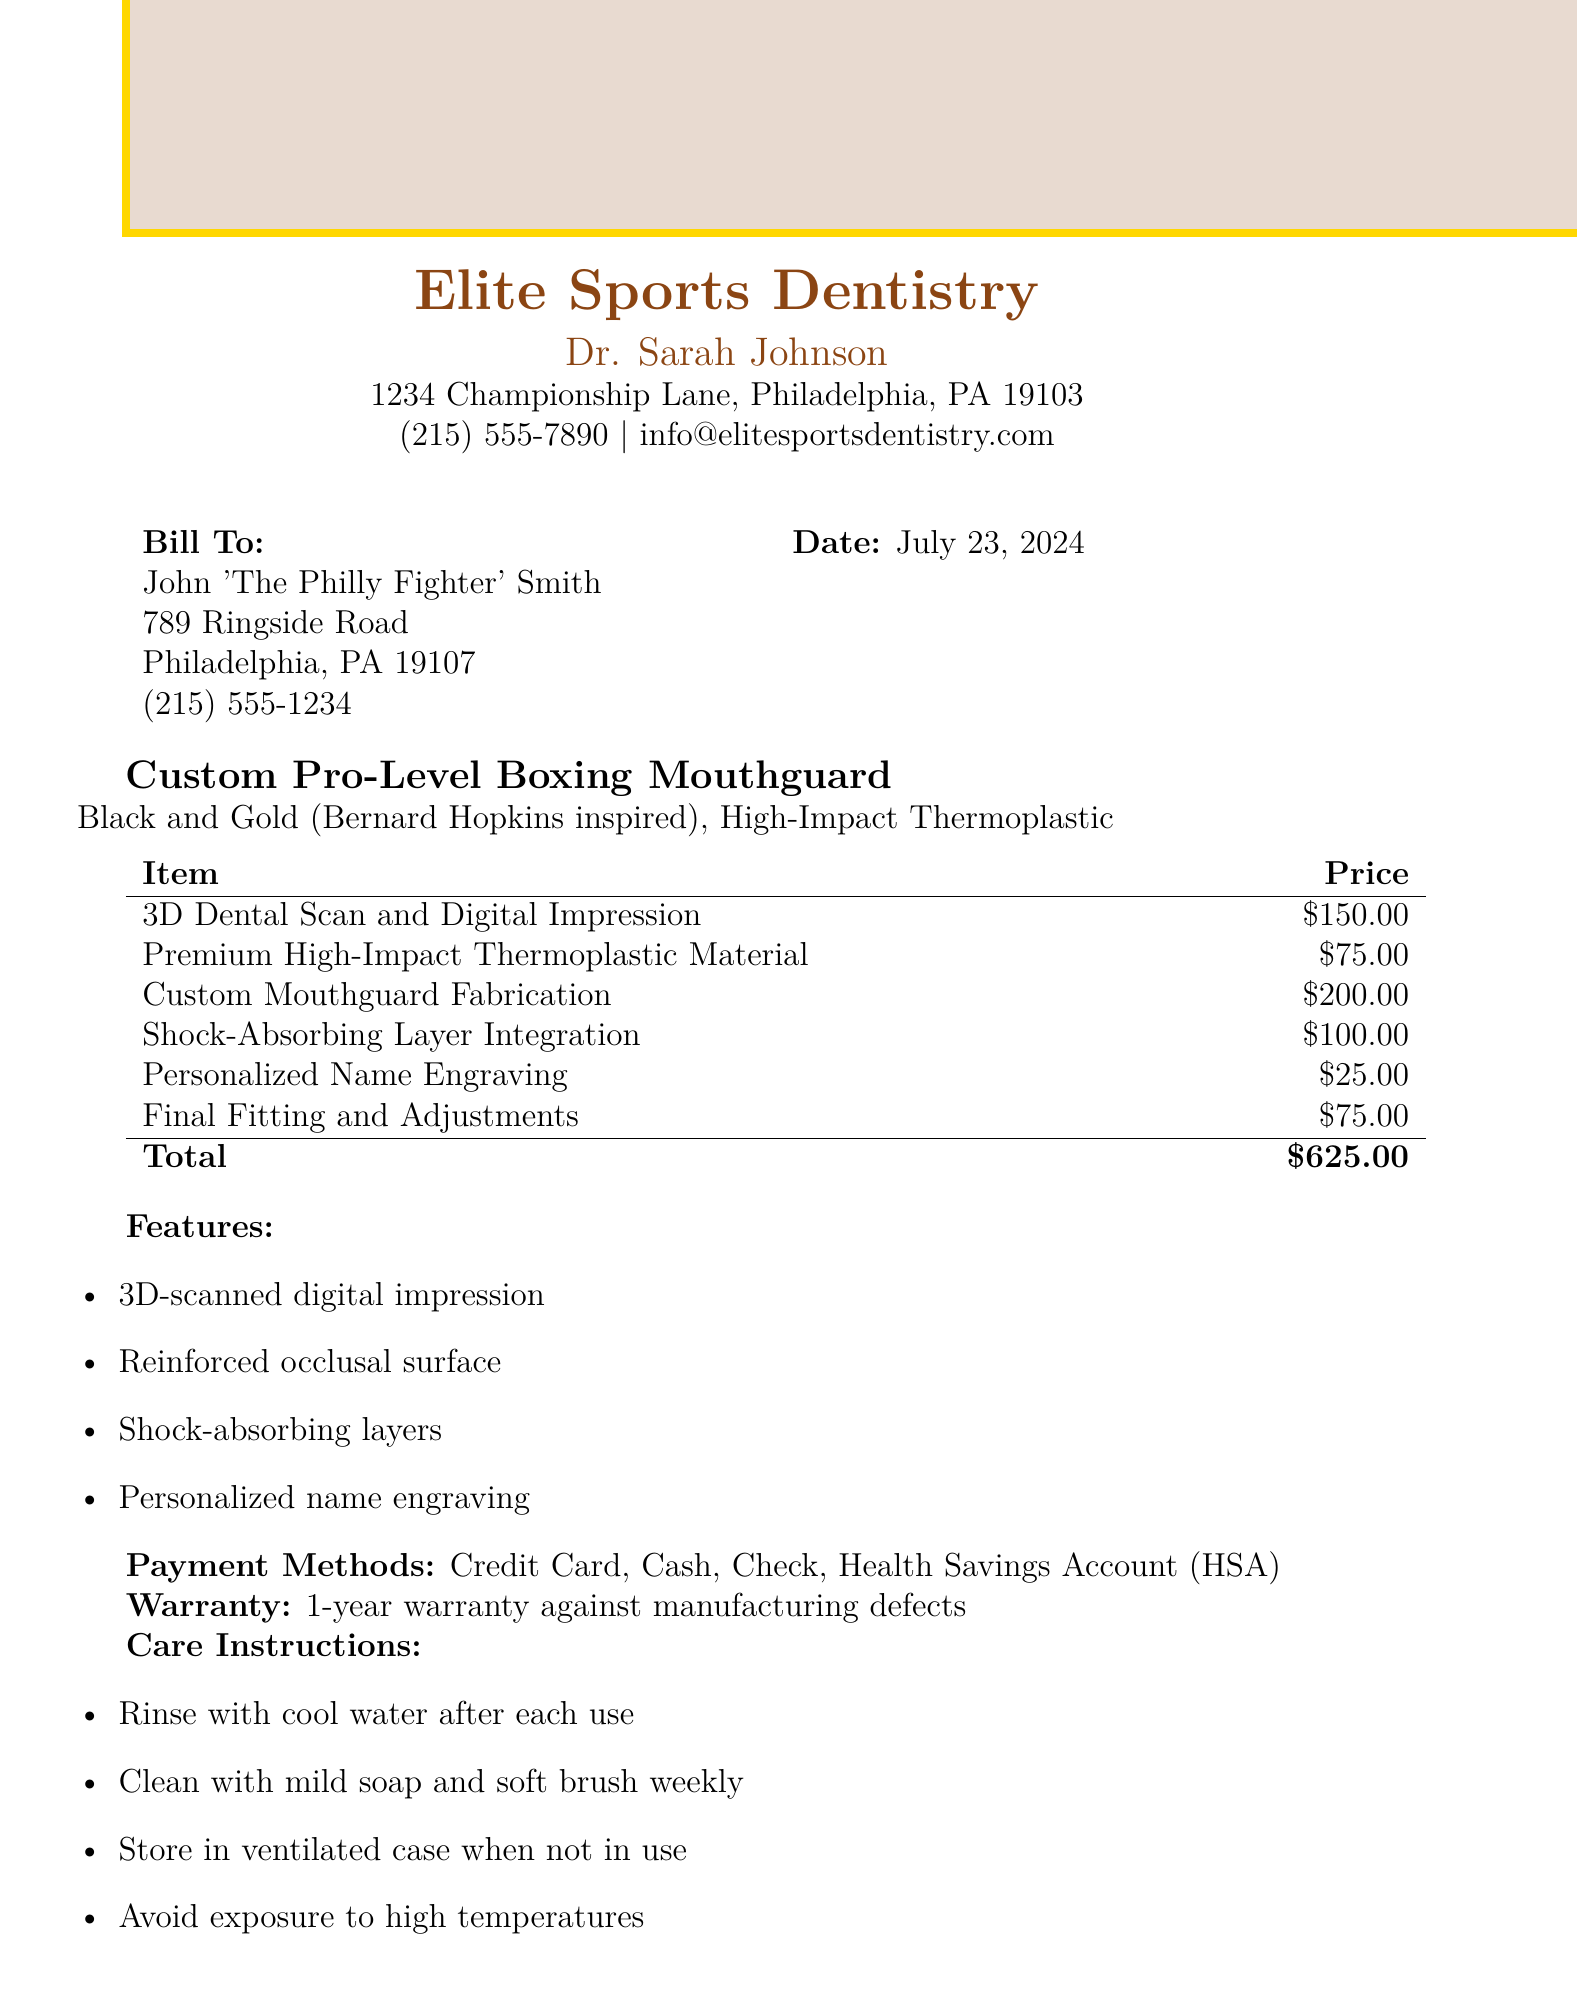What is the name of the dentist? The name of the dentist is listed under the dentist's information in the document.
Answer: Dr. Sarah Johnson What is the total cost of the mouthguard? The total cost is provided clearly at the end of the itemized bill.
Answer: $625.00 What is the type of mouthguard? The type of mouthguard is specified in the mouthguard details section.
Answer: Custom Pro-Level Boxing Mouthguard How many payment methods are listed? The document lists all available payment methods in a specific section.
Answer: 4 What is the warranty duration? The warranty duration is detailed under the warranty section of the document.
Answer: 1-year Which feature includes personalized name engraving? The features section lists different aspects of the mouthguard, including this specific feature.
Answer: Personalized name engraving What is the color scheme of the mouthguard? The color scheme is described in the mouthguard details section as it refers to the design.
Answer: Black and Gold What is the price for Final Fitting and Adjustments? The price for this service is included in the itemized bill section.
Answer: $75.00 What is the profession of the client? The client's profession is mentioned in the introduction of the document related to the client information.
Answer: Boxer 